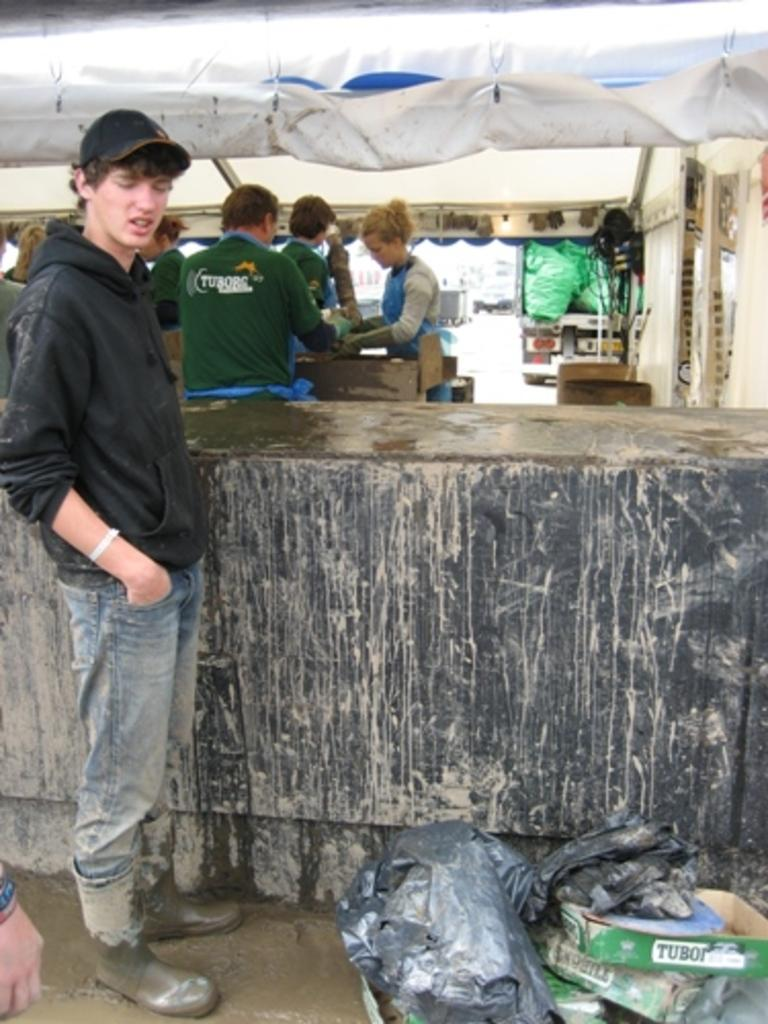How many people are in the image? There are persons in the image, but the exact number is not specified. What is at the top of the image? There is a cover at the top of the image. What is located at the bottom of the image? There are covers and boxes at the bottom of the image. What can be seen on the right side of the image? There is a vehicle on the right side of the image. What type of vase is placed on the person's throat in the image? There is no vase or reference to a throat in the image; it features persons, a cover, covers and boxes, and a vehicle. 